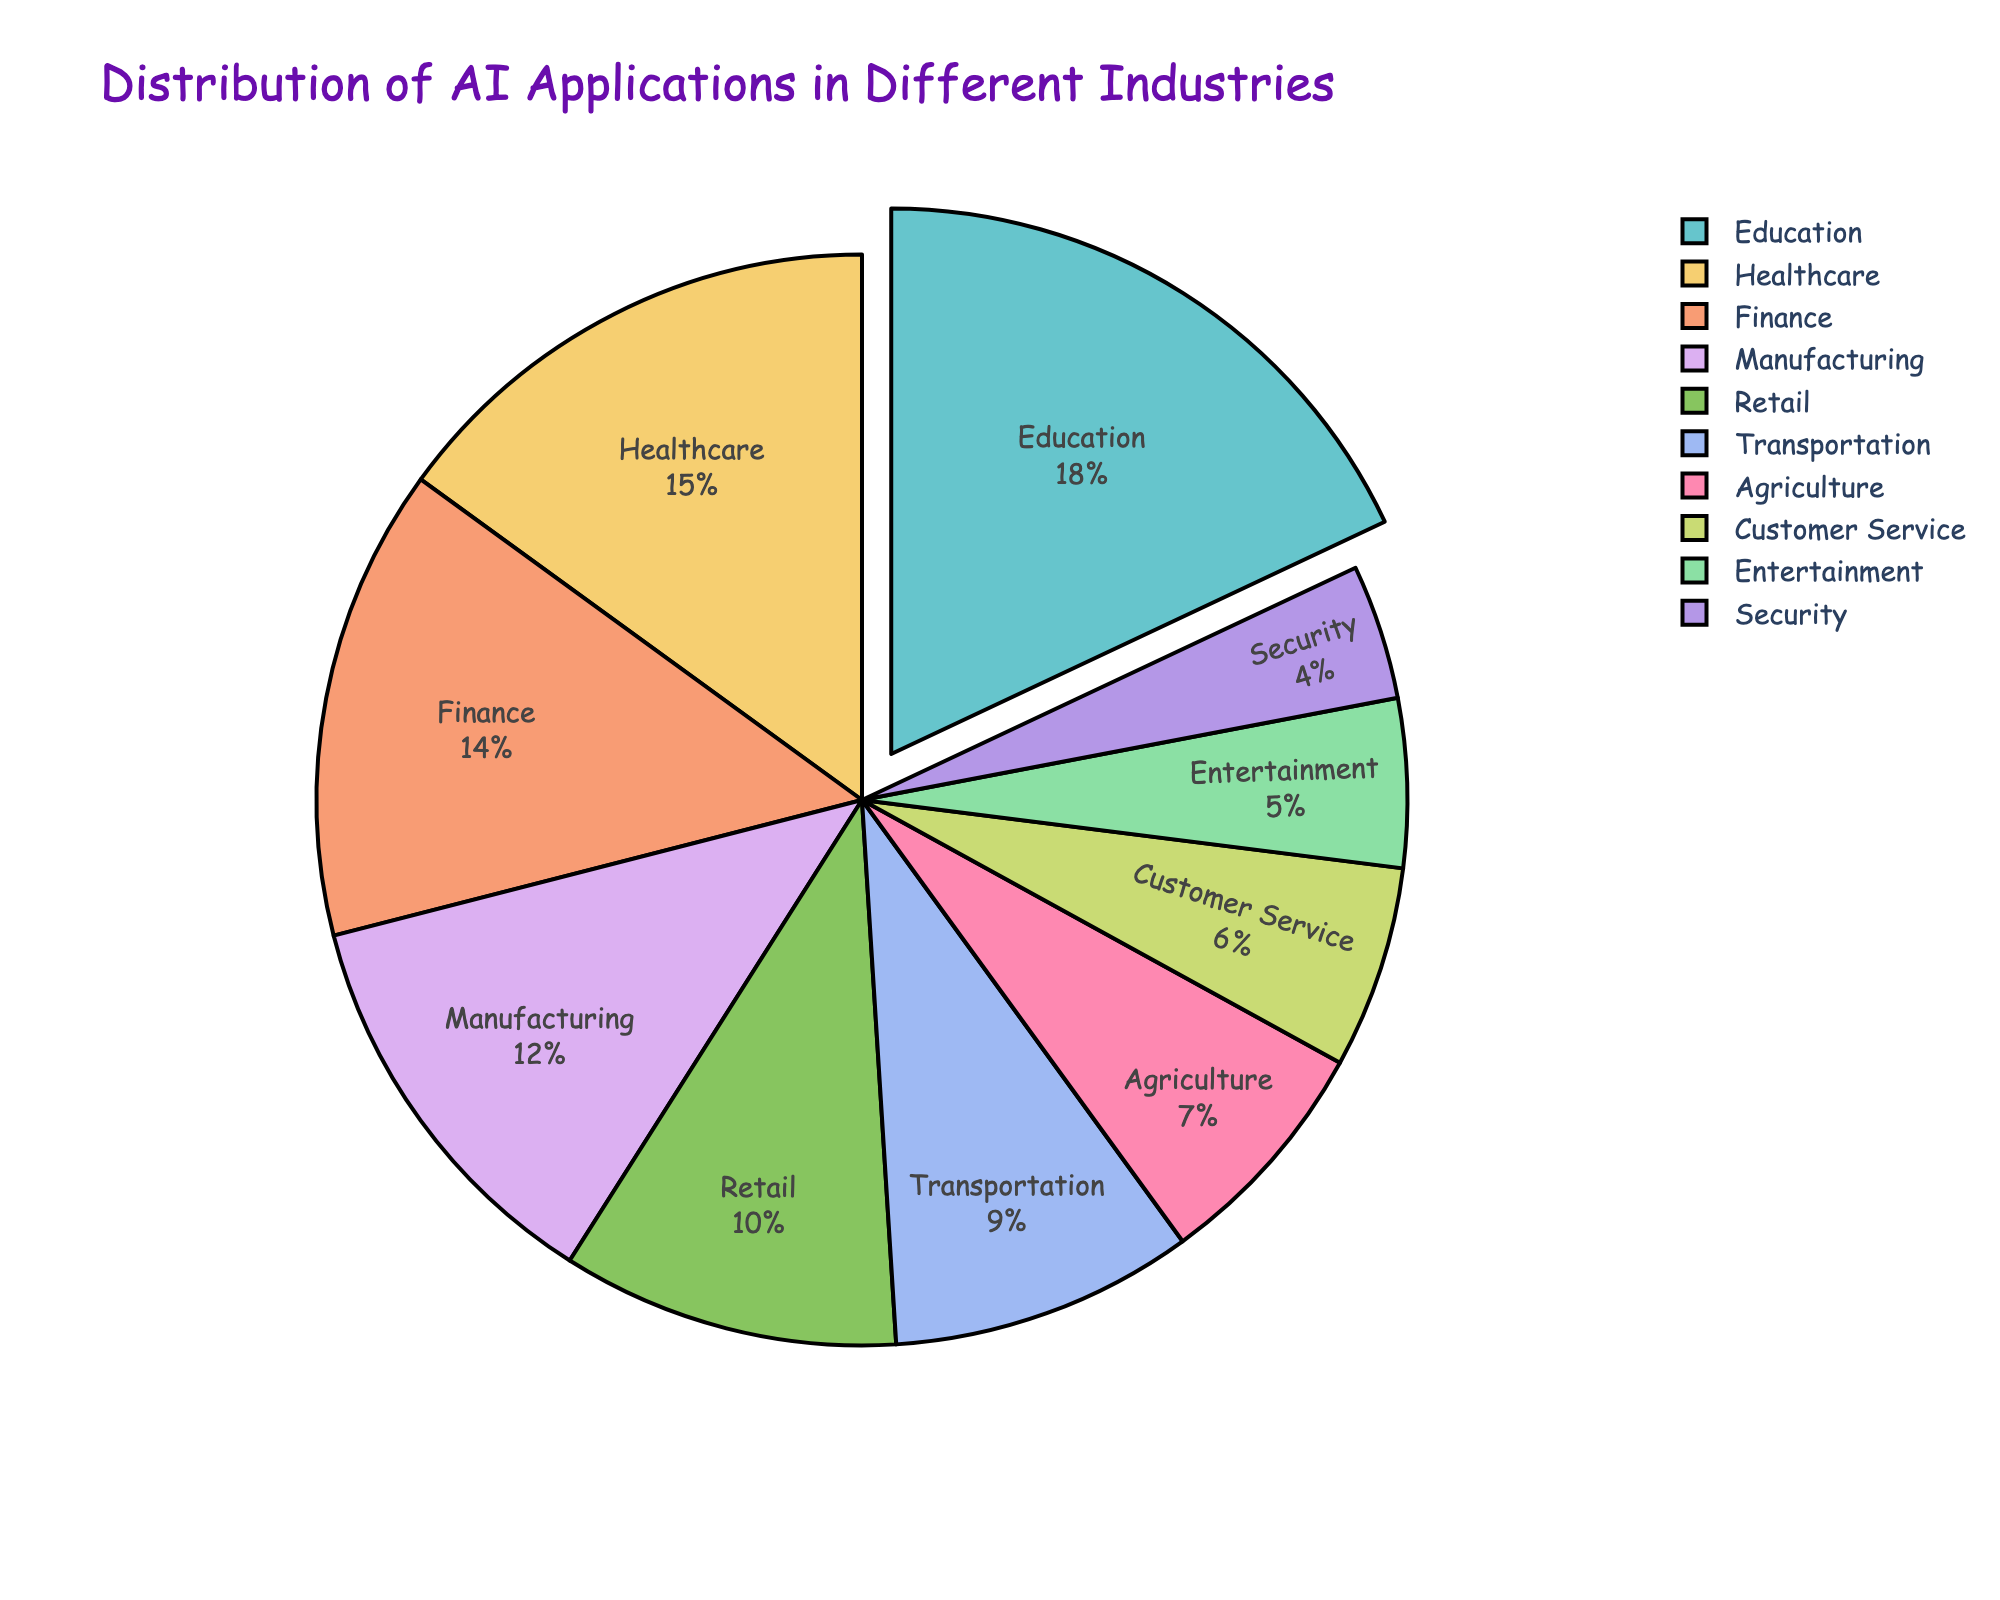What industry has the highest percentage of AI applications? When looking at the pie chart, the "Education" sector is highlighted and appears to have the largest portion. According to the data, Education has 18%.
Answer: Education Which two industries have the smallest percentages of AI applications and what are their values? By glancing at the pie chart, the smallest segments are labeled "Security" and "Entertainment." According to the data, Security has 4% and Entertainment has 5%.
Answer: Security (4%) and Entertainment (5%) How does the percentage of AI applications in Healthcare compare to that in Finance? By noting the percentages from the chart, Healthcare has 15% and Finance has 14%. Comparing the two, Healthcare has a slightly higher percentage than Finance.
Answer: Healthcare (15%) > Finance (14%) What's the total percentage of AI applications in Agriculture, Customer Service, and Entertainment combined? Summing the percentages for Agriculture (7%), Customer Service (6%), and Entertainment (5%) results in 7% + 6% + 5% = 18%.
Answer: 18% What industry is highlighted with some separation in the pie chart, and why? Observing the pie chart, the "Education" sector is slightly pulled out from the rest. This is usually done to emphasize that this industry has the highest proportion, which is 18%.
Answer: Education Which industry has nearly double the percentage of AI applications compared to Transportation? The pie chart shows Transportation at 9%. The chart also shows Education at 18%, which is exactly double that of Transportation.
Answer: Education What is the difference in percentage points between AI applications in Manufacturing and Retail? From the chart, Manufacturing has 12% and Retail has 10%. Subtracting these gives 12% - 10% = 2%.
Answer: 2% How do the percentages of AI applications in Agriculture and Customer Service combined compare to the percentage in Education? Agriculture has 7% and Customer Service has 6%, combined to make 13%. Education has 18%. Comparing 13% to 18%, Education has a higher percentage.
Answer: Education (18%) > Agriculture + Customer Service (13%) What's the combined percentage of AI applications in Finance, Manufacturing, and Retail? The percentages are Finance (14%), Manufacturing (12%), and Retail (10%). Adding them together, 14% + 12% + 10% = 36%.
Answer: 36% If you combine the percentages for Transportation and Security, is it less than Healthcare's percentage? Transportation is 9% and Security is 4%. Combined, they make 9% + 4% = 13%. The Healthcare percentage is 15%. Therefore, 13% is less than 15%.
Answer: Yes 